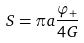Convert formula to latex. <formula><loc_0><loc_0><loc_500><loc_500>S = \pi a \frac { \varphi _ { + } } { 4 G }</formula> 